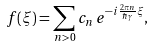Convert formula to latex. <formula><loc_0><loc_0><loc_500><loc_500>f ( \xi ) = \sum _ { n > 0 } c _ { n } \, e ^ { - i \frac { 2 \pi n } { \hbar { \gamma } } \xi } ,</formula> 